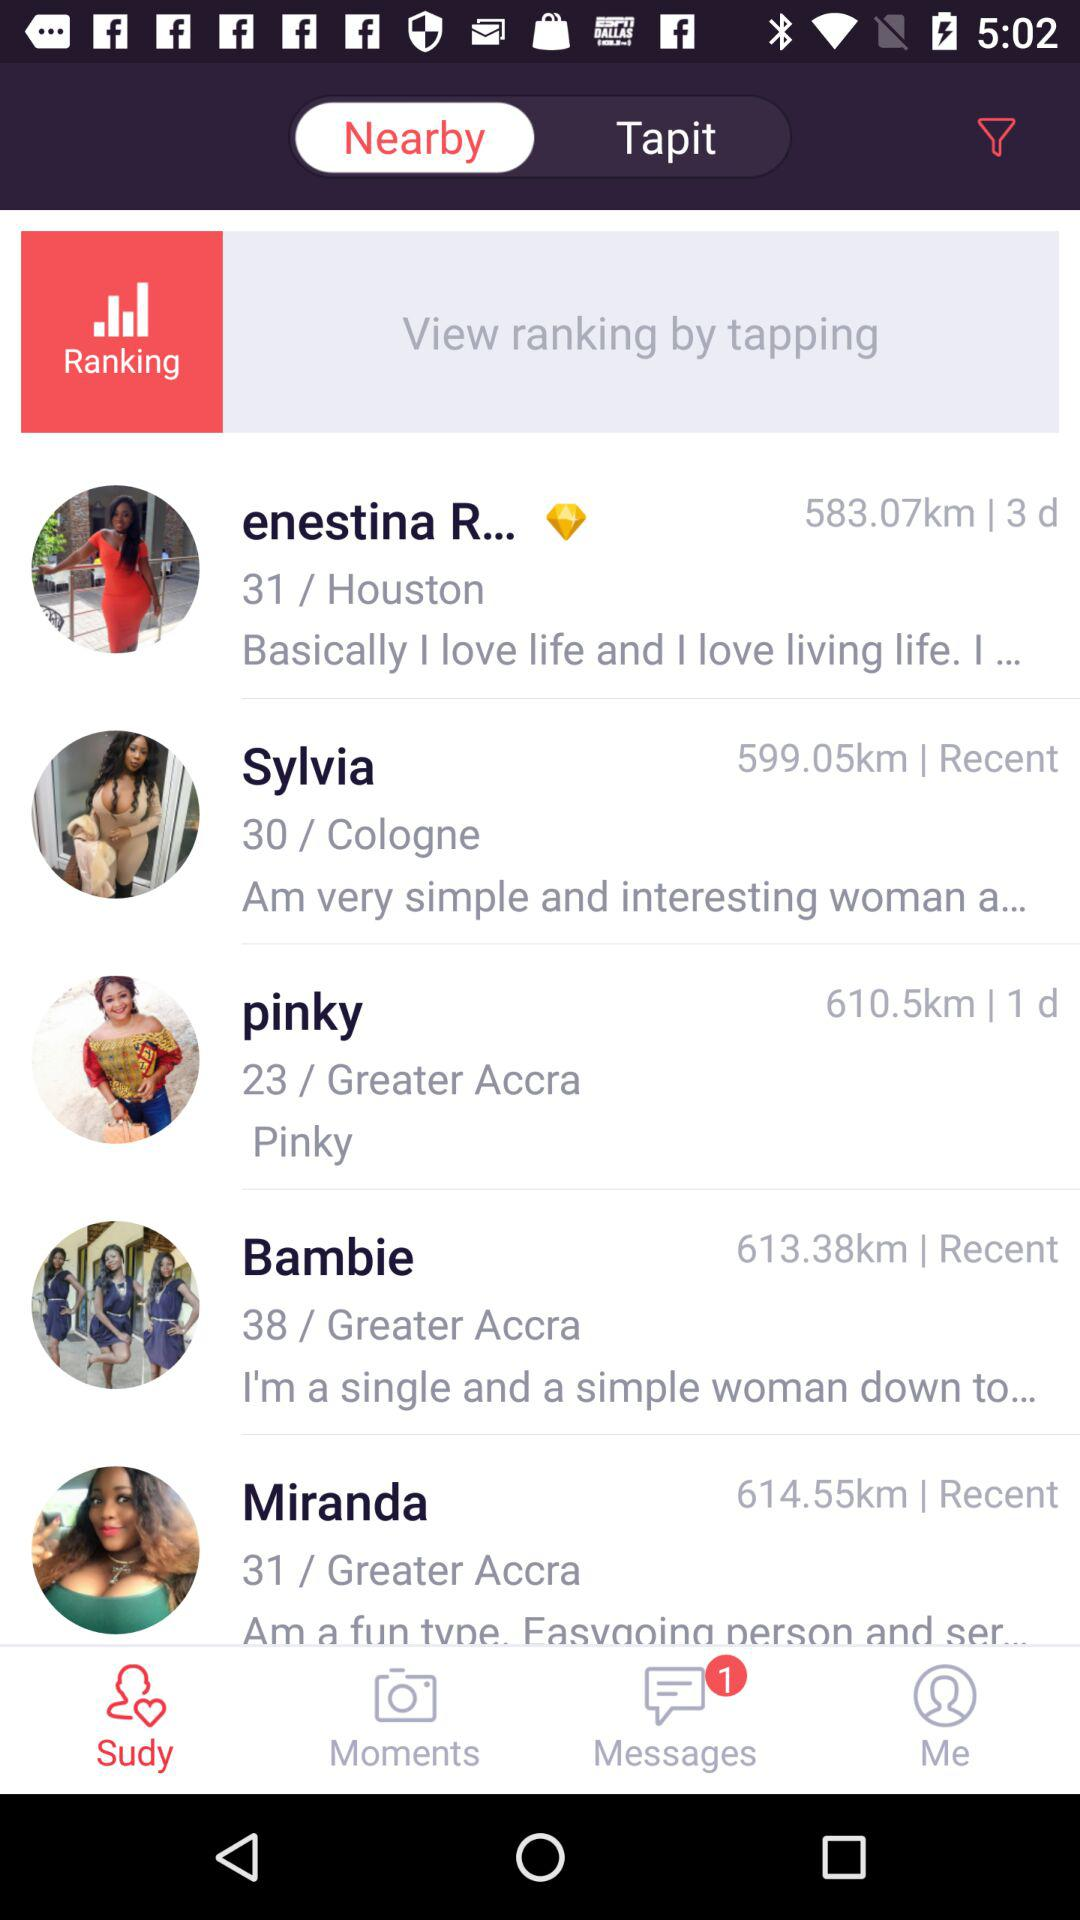How many women are from Greater Accra?
Answer the question using a single word or phrase. 3 